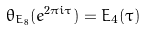<formula> <loc_0><loc_0><loc_500><loc_500>\theta _ { E _ { 8 } } ( e ^ { 2 \pi i \tau } ) = E _ { 4 } ( \tau )</formula> 